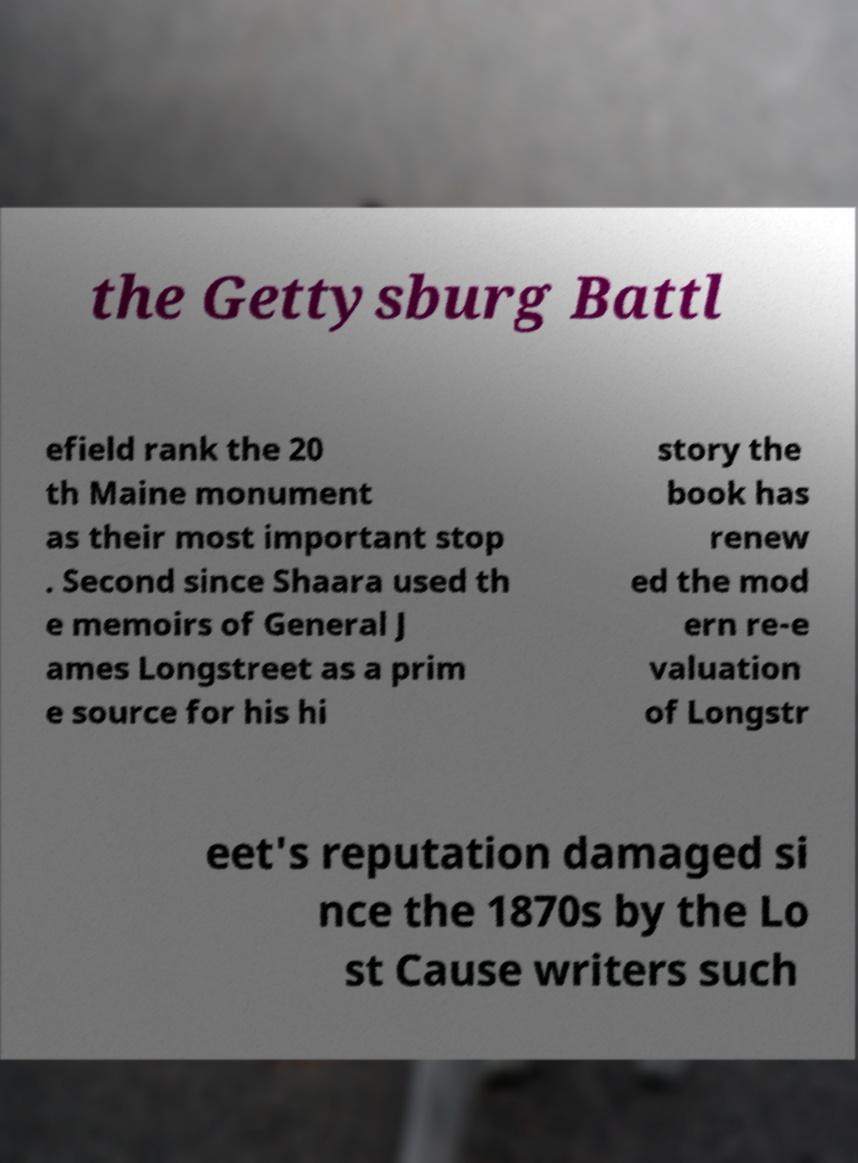For documentation purposes, I need the text within this image transcribed. Could you provide that? the Gettysburg Battl efield rank the 20 th Maine monument as their most important stop . Second since Shaara used th e memoirs of General J ames Longstreet as a prim e source for his hi story the book has renew ed the mod ern re-e valuation of Longstr eet's reputation damaged si nce the 1870s by the Lo st Cause writers such 